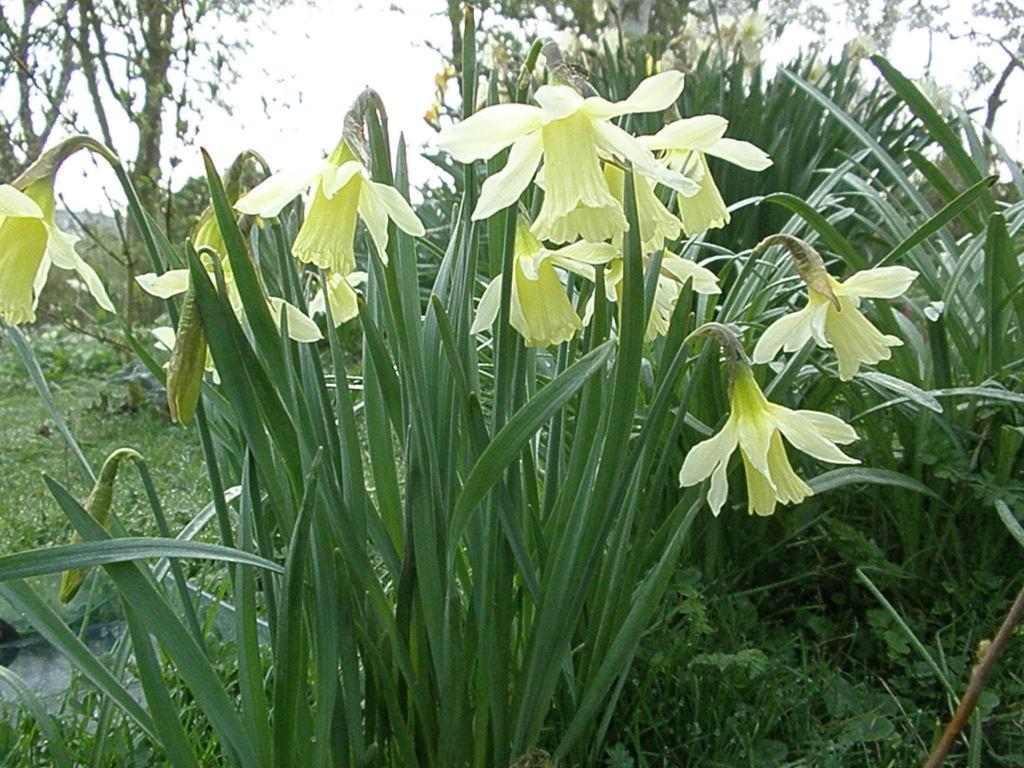Please provide a concise description of this image. In this picture I can see few plants, flowers and few trees in the back and I can see water and a cloudy sky. 